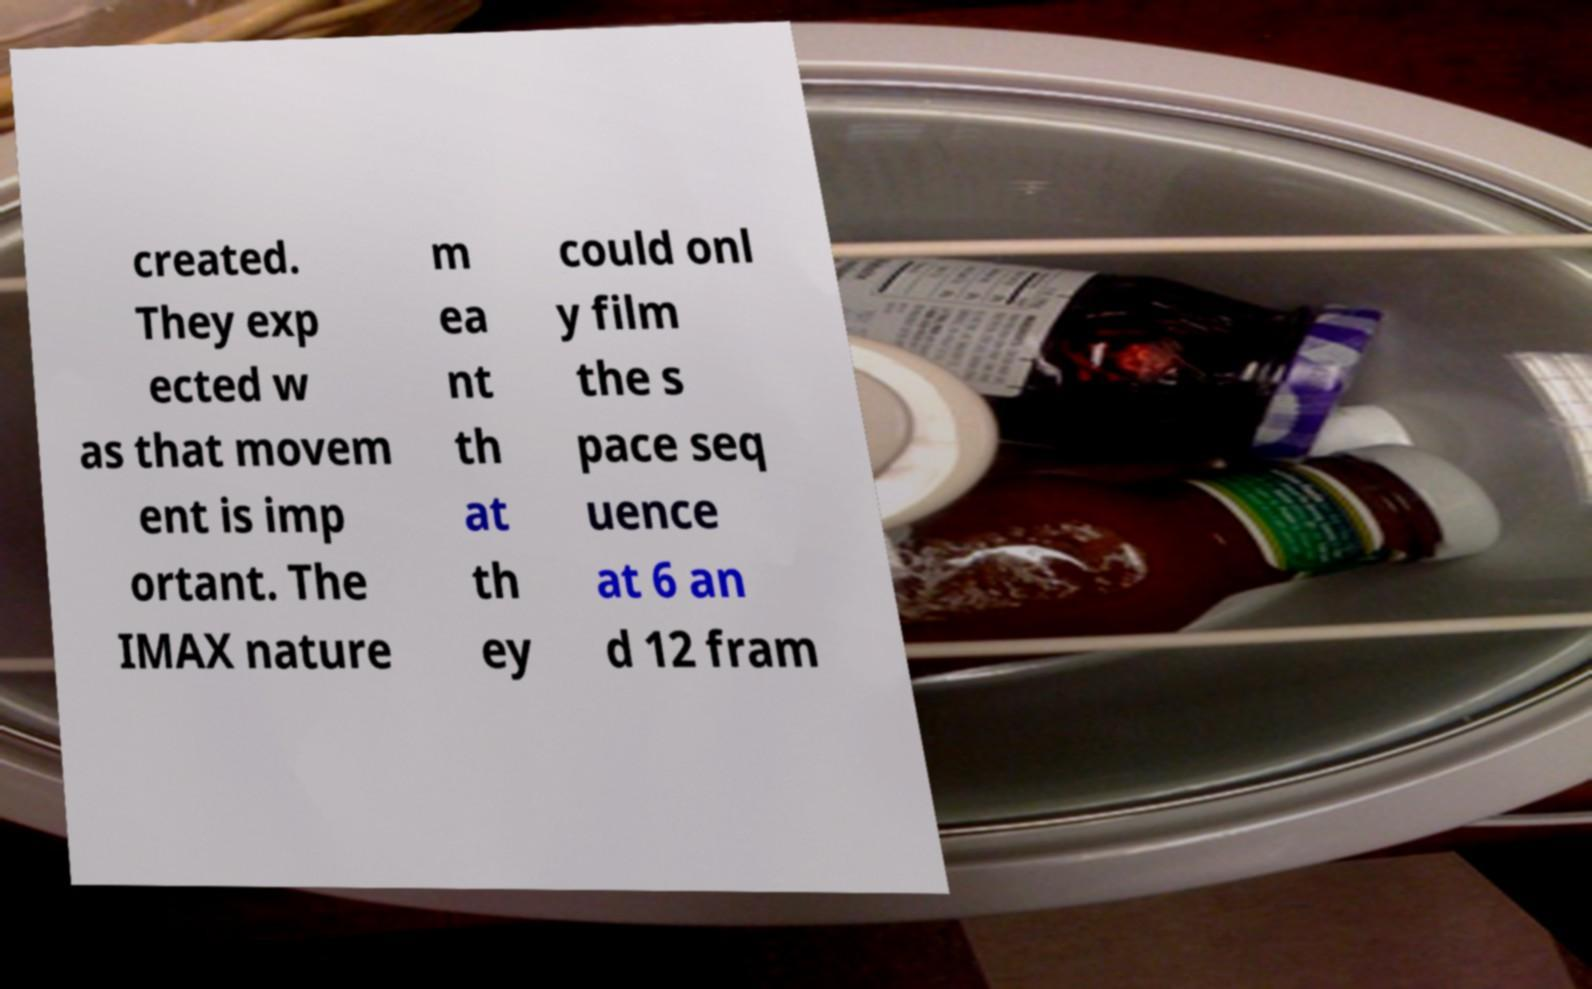Please identify and transcribe the text found in this image. created. They exp ected w as that movem ent is imp ortant. The IMAX nature m ea nt th at th ey could onl y film the s pace seq uence at 6 an d 12 fram 